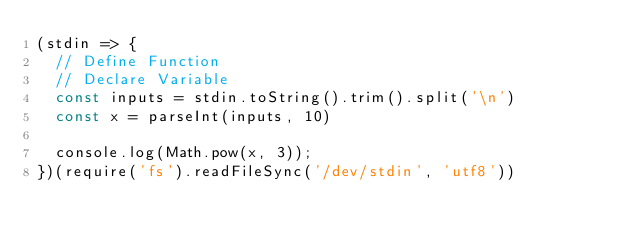<code> <loc_0><loc_0><loc_500><loc_500><_JavaScript_>(stdin => {
  // Define Function
  // Declare Variable
  const inputs = stdin.toString().trim().split('\n')
  const x = parseInt(inputs, 10)

  console.log(Math.pow(x, 3));
})(require('fs').readFileSync('/dev/stdin', 'utf8'))

</code> 